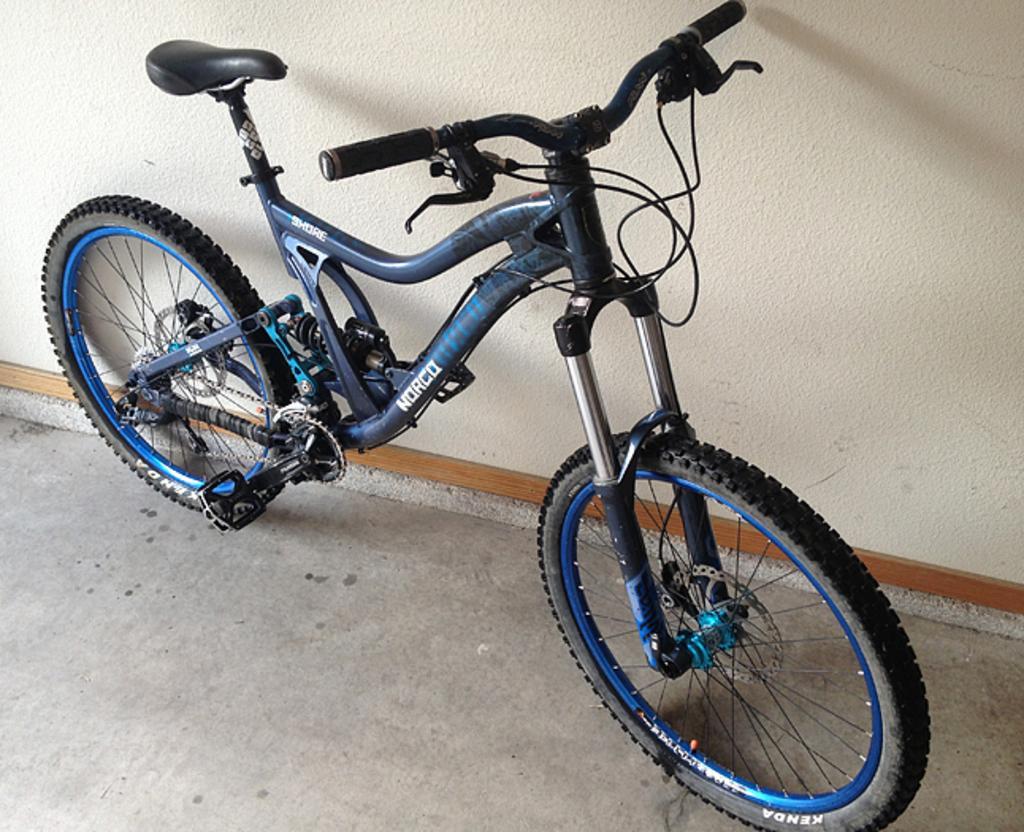Please provide a concise description of this image. In this image there is a bicycle parked on the floor. Behind it there is a wall. 